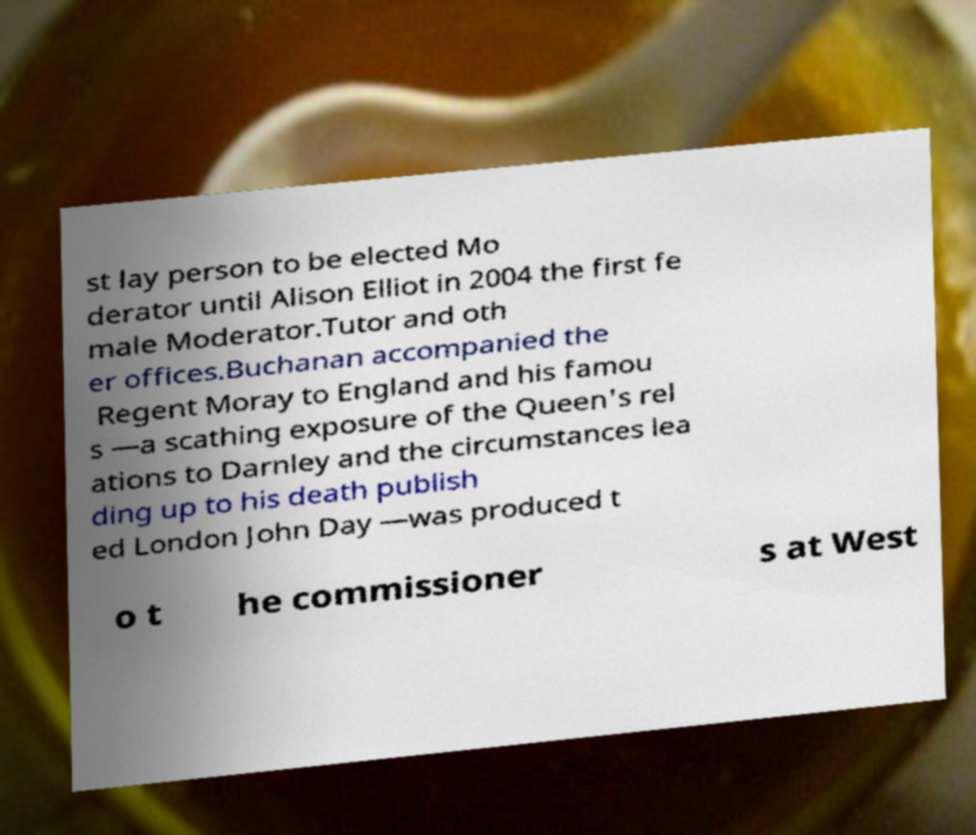Could you extract and type out the text from this image? st lay person to be elected Mo derator until Alison Elliot in 2004 the first fe male Moderator.Tutor and oth er offices.Buchanan accompanied the Regent Moray to England and his famou s —a scathing exposure of the Queen's rel ations to Darnley and the circumstances lea ding up to his death publish ed London John Day —was produced t o t he commissioner s at West 